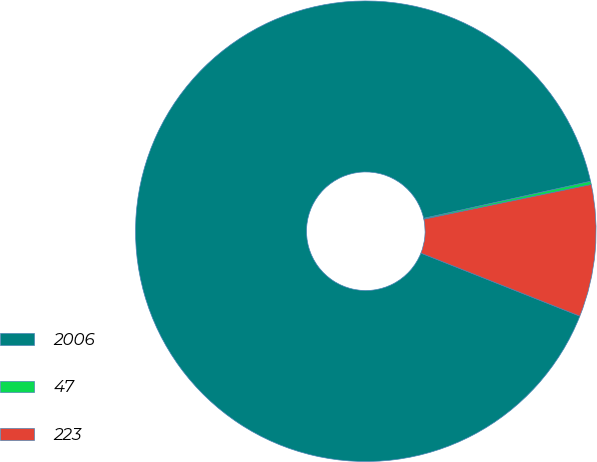<chart> <loc_0><loc_0><loc_500><loc_500><pie_chart><fcel>2006<fcel>47<fcel>223<nl><fcel>90.5%<fcel>0.23%<fcel>9.26%<nl></chart> 